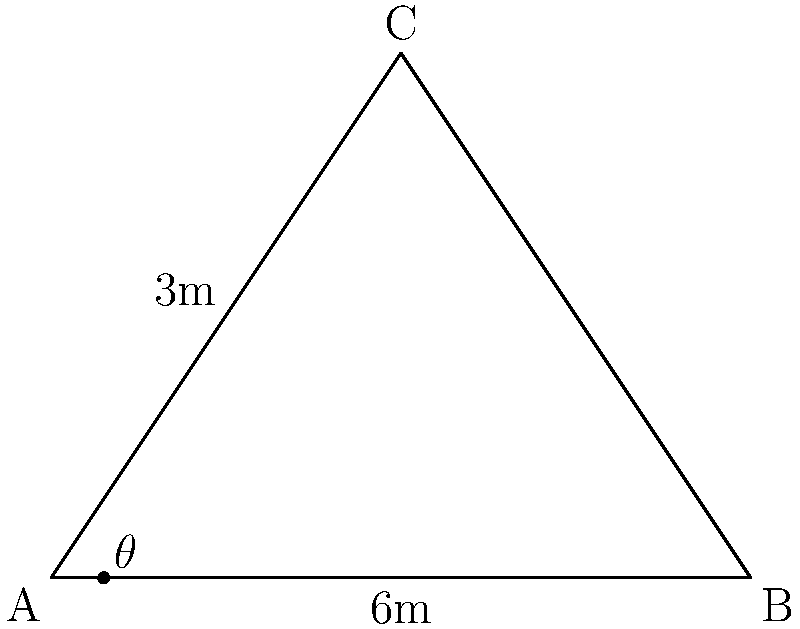Your hermit cousin has decided to build a secluded mountain cabin with a steep roof to shed snow. The cabin's base is 6 meters wide, and the peak of the roof is 3 meters above the midpoint of the base. What is the angle $\theta$ between the roof and the horizontal base? To find the angle $\theta$, we can use the right triangle formed by half of the roof:

1. The base of this triangle is half the cabin width: $6 \div 2 = 3$ meters
2. The height of the triangle is the roof peak height: 3 meters
3. We can use the tangent function to find the angle:

   $\tan(\theta) = \frac{\text{opposite}}{\text{adjacent}} = \frac{3}{3} = 1$

4. To find $\theta$, we take the inverse tangent (arctangent):

   $\theta = \tan^{-1}(1)$

5. The inverse tangent of 1 is 45 degrees

Therefore, the angle between the roof and the horizontal base is 45 degrees.
Answer: 45° 